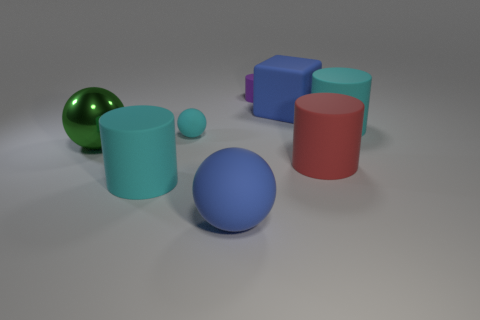Is there any object that appears to be casting a shadow? Yes, every object in the image casts a shadow due to the lighting in the scene. These shadows help in providing depth and enhancing the perception that the objects are three-dimensional. The direction and length of the shadows can also give clues about the light source position and its nature. 